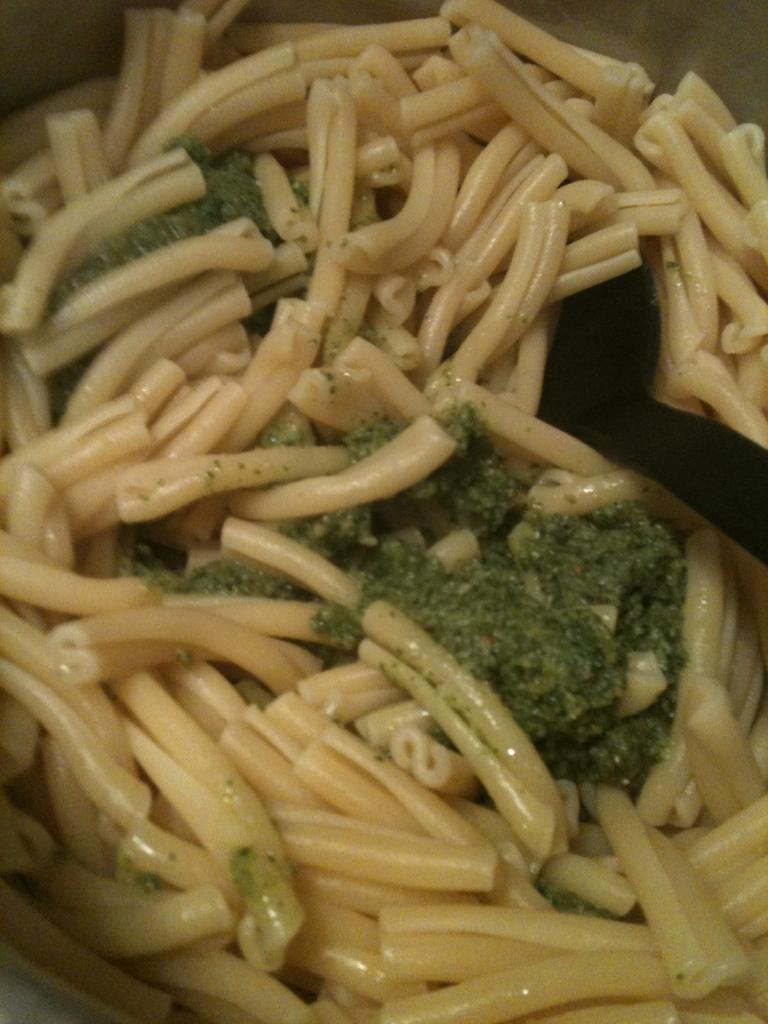What type of food can be seen in the image? There is a food item in the image that contains pastas. Can you describe any specific features of the food item? Yes, there is a green color thing on the food item. What type of balls are being used to celebrate the holiday in the image? There are no balls or holiday celebrations present in the image; it features a food item with pastas and a green color thing. 